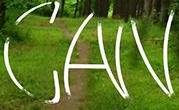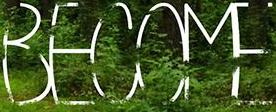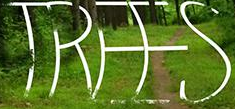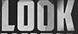Identify the words shown in these images in order, separated by a semicolon. CAN; BECOME; TREES; LOOK 